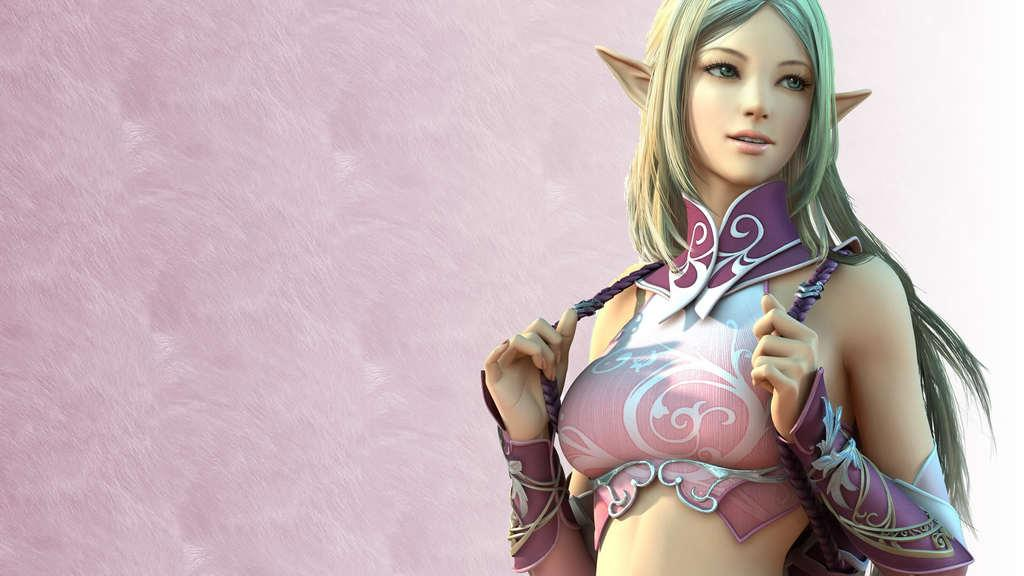What is the main subject of the image? There is a depiction of a woman in the image. What is the woman wearing in the image? The woman is wearing a pink dress in the image. What color can be seen in the background of the image? There is pink color in the background of the image. What is the texture of the bit in the image? There is no bit present in the image, as the facts provided do not mention any such object. 